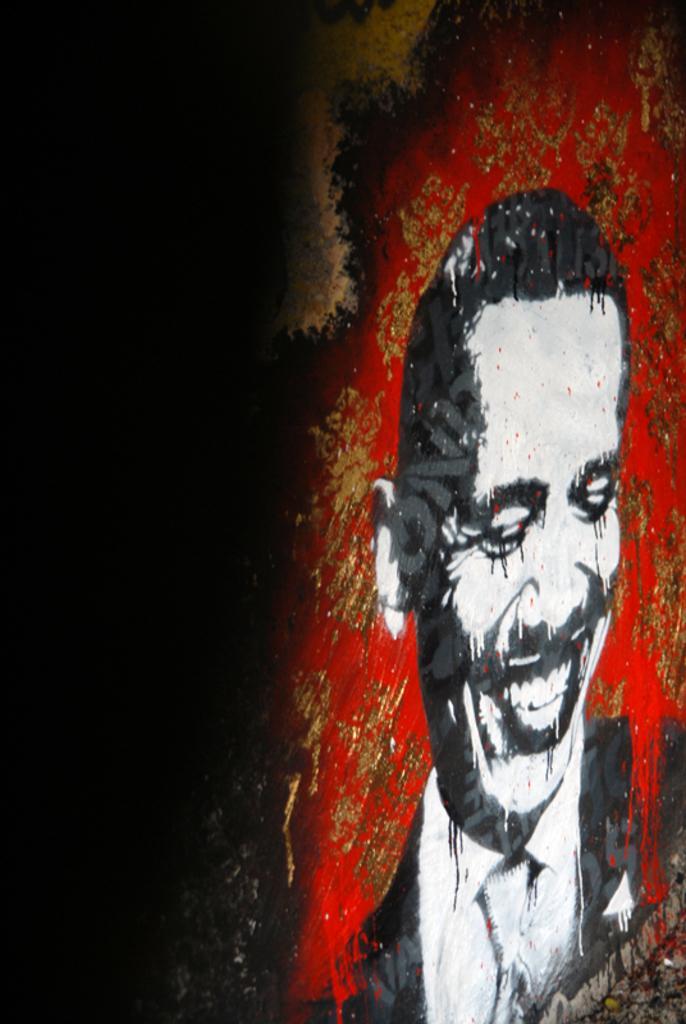How would you summarize this image in a sentence or two? In this image we can see the painting of a person on the wall. 